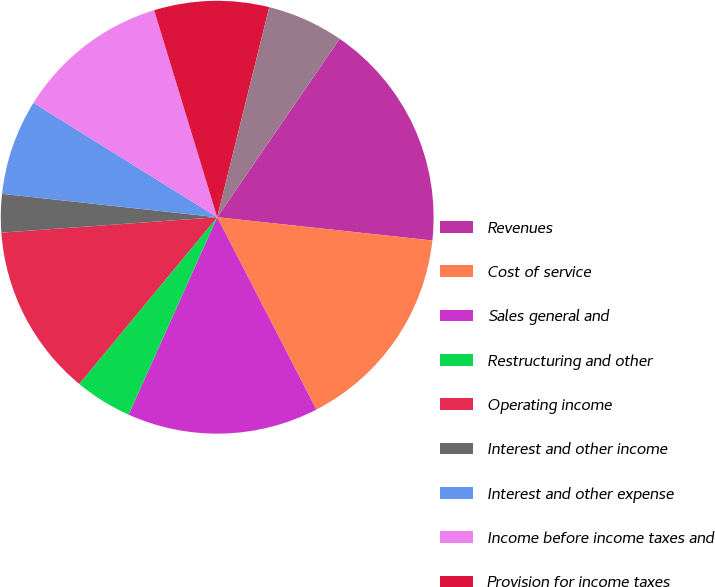Convert chart. <chart><loc_0><loc_0><loc_500><loc_500><pie_chart><fcel>Revenues<fcel>Cost of service<fcel>Sales general and<fcel>Restructuring and other<fcel>Operating income<fcel>Interest and other income<fcel>Interest and other expense<fcel>Income before income taxes and<fcel>Provision for income taxes<fcel>Minority interest net of tax<nl><fcel>17.14%<fcel>15.71%<fcel>14.29%<fcel>4.29%<fcel>12.86%<fcel>2.86%<fcel>7.14%<fcel>11.43%<fcel>8.57%<fcel>5.71%<nl></chart> 